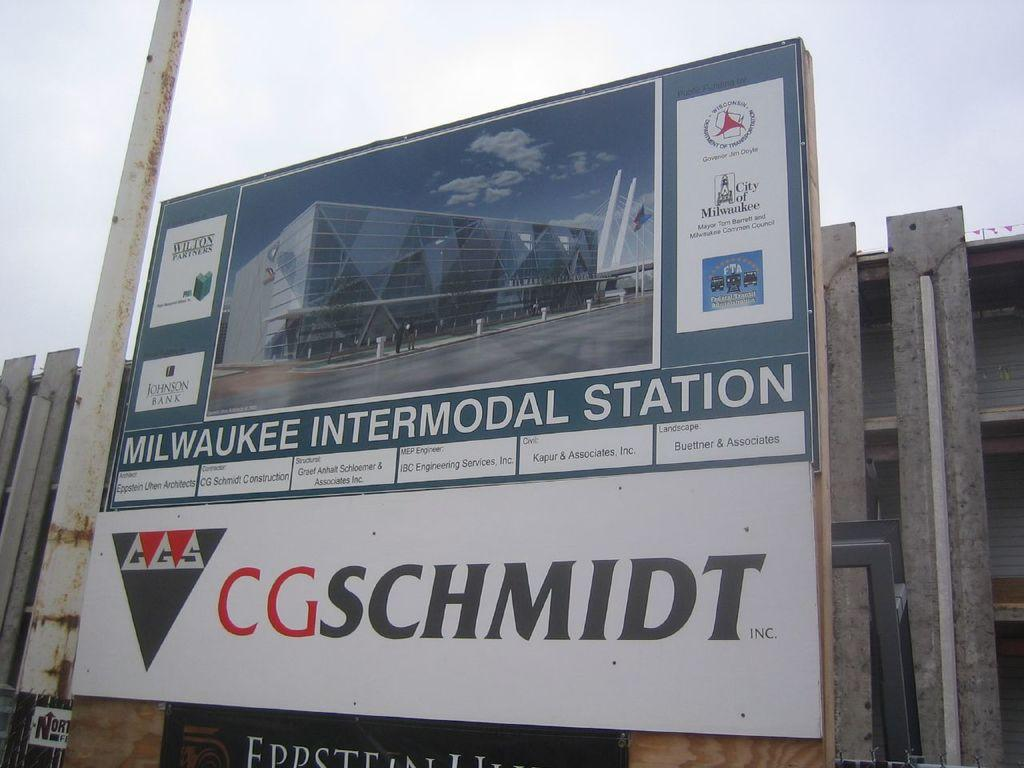<image>
Give a short and clear explanation of the subsequent image. Big billboard sign with the CGSCHMIDT logo and Milwaukee Intermodal Static. 